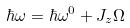Convert formula to latex. <formula><loc_0><loc_0><loc_500><loc_500>\hbar { \omega } = \hbar { \omega } ^ { 0 } + J _ { z } \Omega</formula> 